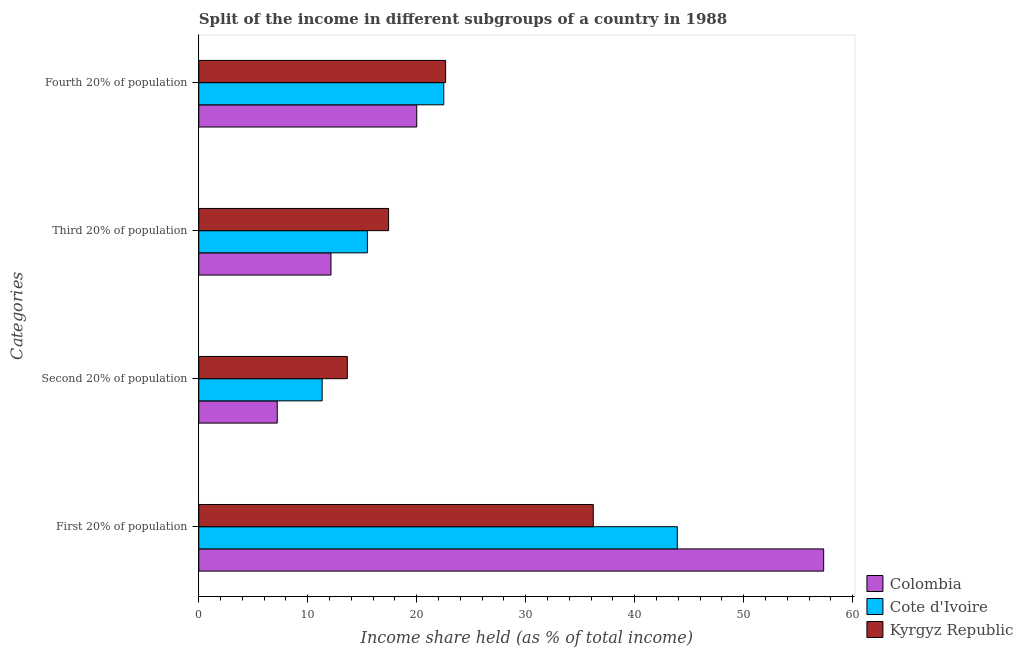How many bars are there on the 1st tick from the bottom?
Keep it short and to the point. 3. What is the label of the 1st group of bars from the top?
Make the answer very short. Fourth 20% of population. Across all countries, what is the maximum share of the income held by second 20% of the population?
Your answer should be very brief. 13.63. Across all countries, what is the minimum share of the income held by second 20% of the population?
Ensure brevity in your answer.  7.2. What is the total share of the income held by first 20% of the population in the graph?
Offer a very short reply. 137.45. What is the difference between the share of the income held by first 20% of the population in Cote d'Ivoire and that in Kyrgyz Republic?
Give a very brief answer. 7.71. What is the difference between the share of the income held by first 20% of the population in Cote d'Ivoire and the share of the income held by third 20% of the population in Colombia?
Provide a succinct answer. 31.78. What is the average share of the income held by fourth 20% of the population per country?
Make the answer very short. 21.71. What is the difference between the share of the income held by third 20% of the population and share of the income held by second 20% of the population in Cote d'Ivoire?
Offer a terse response. 4.15. What is the ratio of the share of the income held by third 20% of the population in Kyrgyz Republic to that in Colombia?
Keep it short and to the point. 1.44. Is the share of the income held by fourth 20% of the population in Cote d'Ivoire less than that in Colombia?
Keep it short and to the point. No. What is the difference between the highest and the second highest share of the income held by second 20% of the population?
Make the answer very short. 2.31. What is the difference between the highest and the lowest share of the income held by third 20% of the population?
Give a very brief answer. 5.29. Is the sum of the share of the income held by second 20% of the population in Cote d'Ivoire and Colombia greater than the maximum share of the income held by first 20% of the population across all countries?
Ensure brevity in your answer.  No. Is it the case that in every country, the sum of the share of the income held by first 20% of the population and share of the income held by third 20% of the population is greater than the sum of share of the income held by second 20% of the population and share of the income held by fourth 20% of the population?
Your response must be concise. Yes. What does the 2nd bar from the top in First 20% of population represents?
Your answer should be compact. Cote d'Ivoire. What does the 3rd bar from the bottom in Third 20% of population represents?
Offer a very short reply. Kyrgyz Republic. Is it the case that in every country, the sum of the share of the income held by first 20% of the population and share of the income held by second 20% of the population is greater than the share of the income held by third 20% of the population?
Provide a succinct answer. Yes. Are all the bars in the graph horizontal?
Offer a very short reply. Yes. How many countries are there in the graph?
Your answer should be very brief. 3. Are the values on the major ticks of X-axis written in scientific E-notation?
Keep it short and to the point. No. Does the graph contain any zero values?
Your answer should be very brief. No. Where does the legend appear in the graph?
Your response must be concise. Bottom right. How many legend labels are there?
Your response must be concise. 3. What is the title of the graph?
Offer a very short reply. Split of the income in different subgroups of a country in 1988. What is the label or title of the X-axis?
Provide a succinct answer. Income share held (as % of total income). What is the label or title of the Y-axis?
Ensure brevity in your answer.  Categories. What is the Income share held (as % of total income) in Colombia in First 20% of population?
Your answer should be very brief. 57.34. What is the Income share held (as % of total income) in Cote d'Ivoire in First 20% of population?
Keep it short and to the point. 43.91. What is the Income share held (as % of total income) of Kyrgyz Republic in First 20% of population?
Your answer should be very brief. 36.2. What is the Income share held (as % of total income) in Cote d'Ivoire in Second 20% of population?
Provide a short and direct response. 11.32. What is the Income share held (as % of total income) of Kyrgyz Republic in Second 20% of population?
Your response must be concise. 13.63. What is the Income share held (as % of total income) in Colombia in Third 20% of population?
Offer a very short reply. 12.13. What is the Income share held (as % of total income) in Cote d'Ivoire in Third 20% of population?
Give a very brief answer. 15.47. What is the Income share held (as % of total income) of Kyrgyz Republic in Third 20% of population?
Offer a terse response. 17.42. What is the Income share held (as % of total income) of Colombia in Fourth 20% of population?
Give a very brief answer. 20. What is the Income share held (as % of total income) of Cote d'Ivoire in Fourth 20% of population?
Keep it short and to the point. 22.48. What is the Income share held (as % of total income) of Kyrgyz Republic in Fourth 20% of population?
Offer a very short reply. 22.65. Across all Categories, what is the maximum Income share held (as % of total income) of Colombia?
Offer a very short reply. 57.34. Across all Categories, what is the maximum Income share held (as % of total income) in Cote d'Ivoire?
Offer a terse response. 43.91. Across all Categories, what is the maximum Income share held (as % of total income) in Kyrgyz Republic?
Give a very brief answer. 36.2. Across all Categories, what is the minimum Income share held (as % of total income) of Cote d'Ivoire?
Make the answer very short. 11.32. Across all Categories, what is the minimum Income share held (as % of total income) in Kyrgyz Republic?
Make the answer very short. 13.63. What is the total Income share held (as % of total income) in Colombia in the graph?
Make the answer very short. 96.67. What is the total Income share held (as % of total income) in Cote d'Ivoire in the graph?
Your answer should be compact. 93.18. What is the total Income share held (as % of total income) of Kyrgyz Republic in the graph?
Keep it short and to the point. 89.9. What is the difference between the Income share held (as % of total income) of Colombia in First 20% of population and that in Second 20% of population?
Offer a very short reply. 50.14. What is the difference between the Income share held (as % of total income) of Cote d'Ivoire in First 20% of population and that in Second 20% of population?
Offer a very short reply. 32.59. What is the difference between the Income share held (as % of total income) in Kyrgyz Republic in First 20% of population and that in Second 20% of population?
Offer a terse response. 22.57. What is the difference between the Income share held (as % of total income) of Colombia in First 20% of population and that in Third 20% of population?
Offer a very short reply. 45.21. What is the difference between the Income share held (as % of total income) of Cote d'Ivoire in First 20% of population and that in Third 20% of population?
Provide a succinct answer. 28.44. What is the difference between the Income share held (as % of total income) in Kyrgyz Republic in First 20% of population and that in Third 20% of population?
Provide a short and direct response. 18.78. What is the difference between the Income share held (as % of total income) of Colombia in First 20% of population and that in Fourth 20% of population?
Your answer should be very brief. 37.34. What is the difference between the Income share held (as % of total income) in Cote d'Ivoire in First 20% of population and that in Fourth 20% of population?
Keep it short and to the point. 21.43. What is the difference between the Income share held (as % of total income) of Kyrgyz Republic in First 20% of population and that in Fourth 20% of population?
Give a very brief answer. 13.55. What is the difference between the Income share held (as % of total income) of Colombia in Second 20% of population and that in Third 20% of population?
Give a very brief answer. -4.93. What is the difference between the Income share held (as % of total income) in Cote d'Ivoire in Second 20% of population and that in Third 20% of population?
Make the answer very short. -4.15. What is the difference between the Income share held (as % of total income) in Kyrgyz Republic in Second 20% of population and that in Third 20% of population?
Your answer should be very brief. -3.79. What is the difference between the Income share held (as % of total income) in Cote d'Ivoire in Second 20% of population and that in Fourth 20% of population?
Ensure brevity in your answer.  -11.16. What is the difference between the Income share held (as % of total income) in Kyrgyz Republic in Second 20% of population and that in Fourth 20% of population?
Offer a very short reply. -9.02. What is the difference between the Income share held (as % of total income) of Colombia in Third 20% of population and that in Fourth 20% of population?
Keep it short and to the point. -7.87. What is the difference between the Income share held (as % of total income) of Cote d'Ivoire in Third 20% of population and that in Fourth 20% of population?
Your answer should be very brief. -7.01. What is the difference between the Income share held (as % of total income) in Kyrgyz Republic in Third 20% of population and that in Fourth 20% of population?
Keep it short and to the point. -5.23. What is the difference between the Income share held (as % of total income) of Colombia in First 20% of population and the Income share held (as % of total income) of Cote d'Ivoire in Second 20% of population?
Keep it short and to the point. 46.02. What is the difference between the Income share held (as % of total income) of Colombia in First 20% of population and the Income share held (as % of total income) of Kyrgyz Republic in Second 20% of population?
Your answer should be compact. 43.71. What is the difference between the Income share held (as % of total income) in Cote d'Ivoire in First 20% of population and the Income share held (as % of total income) in Kyrgyz Republic in Second 20% of population?
Give a very brief answer. 30.28. What is the difference between the Income share held (as % of total income) of Colombia in First 20% of population and the Income share held (as % of total income) of Cote d'Ivoire in Third 20% of population?
Ensure brevity in your answer.  41.87. What is the difference between the Income share held (as % of total income) of Colombia in First 20% of population and the Income share held (as % of total income) of Kyrgyz Republic in Third 20% of population?
Provide a succinct answer. 39.92. What is the difference between the Income share held (as % of total income) of Cote d'Ivoire in First 20% of population and the Income share held (as % of total income) of Kyrgyz Republic in Third 20% of population?
Offer a very short reply. 26.49. What is the difference between the Income share held (as % of total income) in Colombia in First 20% of population and the Income share held (as % of total income) in Cote d'Ivoire in Fourth 20% of population?
Offer a very short reply. 34.86. What is the difference between the Income share held (as % of total income) of Colombia in First 20% of population and the Income share held (as % of total income) of Kyrgyz Republic in Fourth 20% of population?
Provide a short and direct response. 34.69. What is the difference between the Income share held (as % of total income) of Cote d'Ivoire in First 20% of population and the Income share held (as % of total income) of Kyrgyz Republic in Fourth 20% of population?
Make the answer very short. 21.26. What is the difference between the Income share held (as % of total income) of Colombia in Second 20% of population and the Income share held (as % of total income) of Cote d'Ivoire in Third 20% of population?
Offer a terse response. -8.27. What is the difference between the Income share held (as % of total income) in Colombia in Second 20% of population and the Income share held (as % of total income) in Kyrgyz Republic in Third 20% of population?
Your answer should be very brief. -10.22. What is the difference between the Income share held (as % of total income) of Cote d'Ivoire in Second 20% of population and the Income share held (as % of total income) of Kyrgyz Republic in Third 20% of population?
Offer a terse response. -6.1. What is the difference between the Income share held (as % of total income) of Colombia in Second 20% of population and the Income share held (as % of total income) of Cote d'Ivoire in Fourth 20% of population?
Ensure brevity in your answer.  -15.28. What is the difference between the Income share held (as % of total income) in Colombia in Second 20% of population and the Income share held (as % of total income) in Kyrgyz Republic in Fourth 20% of population?
Provide a succinct answer. -15.45. What is the difference between the Income share held (as % of total income) in Cote d'Ivoire in Second 20% of population and the Income share held (as % of total income) in Kyrgyz Republic in Fourth 20% of population?
Ensure brevity in your answer.  -11.33. What is the difference between the Income share held (as % of total income) of Colombia in Third 20% of population and the Income share held (as % of total income) of Cote d'Ivoire in Fourth 20% of population?
Keep it short and to the point. -10.35. What is the difference between the Income share held (as % of total income) in Colombia in Third 20% of population and the Income share held (as % of total income) in Kyrgyz Republic in Fourth 20% of population?
Provide a succinct answer. -10.52. What is the difference between the Income share held (as % of total income) in Cote d'Ivoire in Third 20% of population and the Income share held (as % of total income) in Kyrgyz Republic in Fourth 20% of population?
Your response must be concise. -7.18. What is the average Income share held (as % of total income) in Colombia per Categories?
Provide a short and direct response. 24.17. What is the average Income share held (as % of total income) in Cote d'Ivoire per Categories?
Your response must be concise. 23.3. What is the average Income share held (as % of total income) in Kyrgyz Republic per Categories?
Give a very brief answer. 22.48. What is the difference between the Income share held (as % of total income) of Colombia and Income share held (as % of total income) of Cote d'Ivoire in First 20% of population?
Make the answer very short. 13.43. What is the difference between the Income share held (as % of total income) in Colombia and Income share held (as % of total income) in Kyrgyz Republic in First 20% of population?
Provide a short and direct response. 21.14. What is the difference between the Income share held (as % of total income) of Cote d'Ivoire and Income share held (as % of total income) of Kyrgyz Republic in First 20% of population?
Make the answer very short. 7.71. What is the difference between the Income share held (as % of total income) of Colombia and Income share held (as % of total income) of Cote d'Ivoire in Second 20% of population?
Offer a terse response. -4.12. What is the difference between the Income share held (as % of total income) of Colombia and Income share held (as % of total income) of Kyrgyz Republic in Second 20% of population?
Give a very brief answer. -6.43. What is the difference between the Income share held (as % of total income) of Cote d'Ivoire and Income share held (as % of total income) of Kyrgyz Republic in Second 20% of population?
Your answer should be very brief. -2.31. What is the difference between the Income share held (as % of total income) in Colombia and Income share held (as % of total income) in Cote d'Ivoire in Third 20% of population?
Provide a short and direct response. -3.34. What is the difference between the Income share held (as % of total income) in Colombia and Income share held (as % of total income) in Kyrgyz Republic in Third 20% of population?
Offer a terse response. -5.29. What is the difference between the Income share held (as % of total income) in Cote d'Ivoire and Income share held (as % of total income) in Kyrgyz Republic in Third 20% of population?
Offer a very short reply. -1.95. What is the difference between the Income share held (as % of total income) of Colombia and Income share held (as % of total income) of Cote d'Ivoire in Fourth 20% of population?
Keep it short and to the point. -2.48. What is the difference between the Income share held (as % of total income) in Colombia and Income share held (as % of total income) in Kyrgyz Republic in Fourth 20% of population?
Your response must be concise. -2.65. What is the difference between the Income share held (as % of total income) in Cote d'Ivoire and Income share held (as % of total income) in Kyrgyz Republic in Fourth 20% of population?
Keep it short and to the point. -0.17. What is the ratio of the Income share held (as % of total income) of Colombia in First 20% of population to that in Second 20% of population?
Give a very brief answer. 7.96. What is the ratio of the Income share held (as % of total income) in Cote d'Ivoire in First 20% of population to that in Second 20% of population?
Your response must be concise. 3.88. What is the ratio of the Income share held (as % of total income) of Kyrgyz Republic in First 20% of population to that in Second 20% of population?
Ensure brevity in your answer.  2.66. What is the ratio of the Income share held (as % of total income) in Colombia in First 20% of population to that in Third 20% of population?
Offer a very short reply. 4.73. What is the ratio of the Income share held (as % of total income) of Cote d'Ivoire in First 20% of population to that in Third 20% of population?
Provide a succinct answer. 2.84. What is the ratio of the Income share held (as % of total income) in Kyrgyz Republic in First 20% of population to that in Third 20% of population?
Offer a terse response. 2.08. What is the ratio of the Income share held (as % of total income) in Colombia in First 20% of population to that in Fourth 20% of population?
Offer a terse response. 2.87. What is the ratio of the Income share held (as % of total income) in Cote d'Ivoire in First 20% of population to that in Fourth 20% of population?
Provide a short and direct response. 1.95. What is the ratio of the Income share held (as % of total income) in Kyrgyz Republic in First 20% of population to that in Fourth 20% of population?
Make the answer very short. 1.6. What is the ratio of the Income share held (as % of total income) in Colombia in Second 20% of population to that in Third 20% of population?
Your answer should be very brief. 0.59. What is the ratio of the Income share held (as % of total income) of Cote d'Ivoire in Second 20% of population to that in Third 20% of population?
Offer a very short reply. 0.73. What is the ratio of the Income share held (as % of total income) in Kyrgyz Republic in Second 20% of population to that in Third 20% of population?
Give a very brief answer. 0.78. What is the ratio of the Income share held (as % of total income) of Colombia in Second 20% of population to that in Fourth 20% of population?
Your answer should be very brief. 0.36. What is the ratio of the Income share held (as % of total income) of Cote d'Ivoire in Second 20% of population to that in Fourth 20% of population?
Ensure brevity in your answer.  0.5. What is the ratio of the Income share held (as % of total income) of Kyrgyz Republic in Second 20% of population to that in Fourth 20% of population?
Ensure brevity in your answer.  0.6. What is the ratio of the Income share held (as % of total income) of Colombia in Third 20% of population to that in Fourth 20% of population?
Keep it short and to the point. 0.61. What is the ratio of the Income share held (as % of total income) in Cote d'Ivoire in Third 20% of population to that in Fourth 20% of population?
Your answer should be very brief. 0.69. What is the ratio of the Income share held (as % of total income) in Kyrgyz Republic in Third 20% of population to that in Fourth 20% of population?
Keep it short and to the point. 0.77. What is the difference between the highest and the second highest Income share held (as % of total income) of Colombia?
Provide a short and direct response. 37.34. What is the difference between the highest and the second highest Income share held (as % of total income) of Cote d'Ivoire?
Your response must be concise. 21.43. What is the difference between the highest and the second highest Income share held (as % of total income) of Kyrgyz Republic?
Ensure brevity in your answer.  13.55. What is the difference between the highest and the lowest Income share held (as % of total income) in Colombia?
Provide a succinct answer. 50.14. What is the difference between the highest and the lowest Income share held (as % of total income) of Cote d'Ivoire?
Your answer should be compact. 32.59. What is the difference between the highest and the lowest Income share held (as % of total income) of Kyrgyz Republic?
Provide a short and direct response. 22.57. 